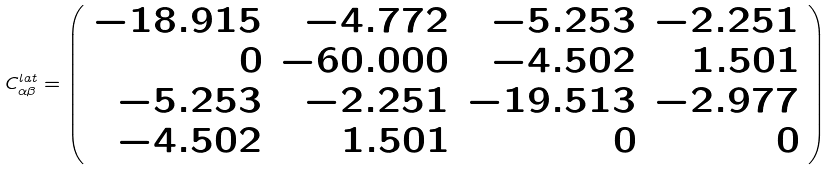Convert formula to latex. <formula><loc_0><loc_0><loc_500><loc_500>C _ { \alpha \beta } ^ { l a t } = \left ( \begin{array} { r r r r } - 1 8 . 9 1 5 & - 4 . 7 7 2 & - 5 . 2 5 3 & - 2 . 2 5 1 \\ 0 & - 6 0 . 0 0 0 & - 4 . 5 0 2 & 1 . 5 0 1 \\ - 5 . 2 5 3 & - 2 . 2 5 1 & - 1 9 . 5 1 3 & - 2 . 9 7 7 \\ - 4 . 5 0 2 & 1 . 5 0 1 & 0 & 0 \\ \end{array} \right )</formula> 